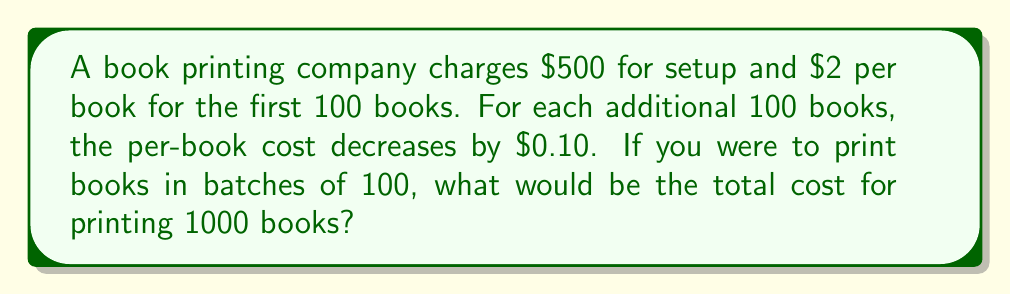Can you solve this math problem? Let's approach this step-by-step:

1) First, we need to identify the arithmetic sequence for the per-book cost:
   $\$2.00, \$1.90, \$1.80, \$1.70, ...$

2) This sequence has 10 terms (for 1000 books in batches of 100).
   The common difference is $d = -\$0.10$.

3) We can find the last term using the arithmetic sequence formula:
   $a_n = a_1 + (n-1)d$
   $a_{10} = 2 + (10-1)(-0.10) = 2 - 0.90 = \$1.10$

4) Now, we need to find the sum of this sequence. We can use the arithmetic series formula:
   $S_n = \frac{n}{2}(a_1 + a_n)$
   $S_{10} = \frac{10}{2}(2.00 + 1.10) = 5(3.10) = \$15.50$

5) This $\$15.50$ represents the total per-book cost for all 1000 books.
   To get the total cost for the books: $1000 * \$15.50 = \$15,500$

6) Don't forget the setup cost: $\$15,500 + \$500 = \$16,000$

Therefore, the total cost for printing 1000 books would be $\$16,000$.
Answer: $\$16,000$ 